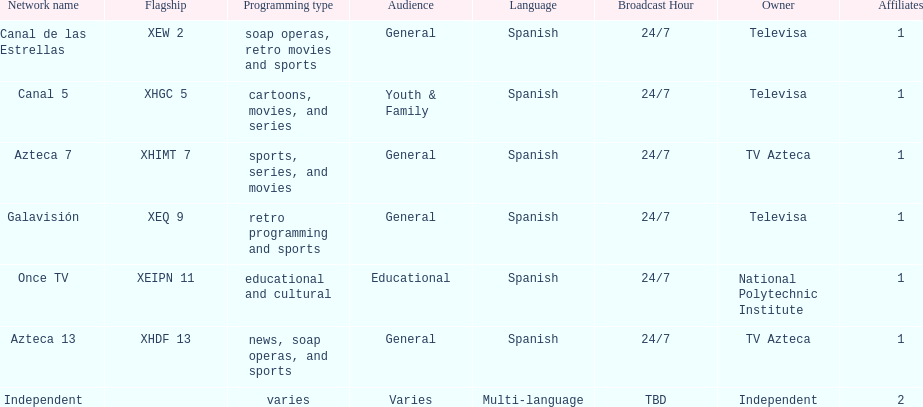Who is the only network owner listed in a consecutive order in the chart? Televisa. 